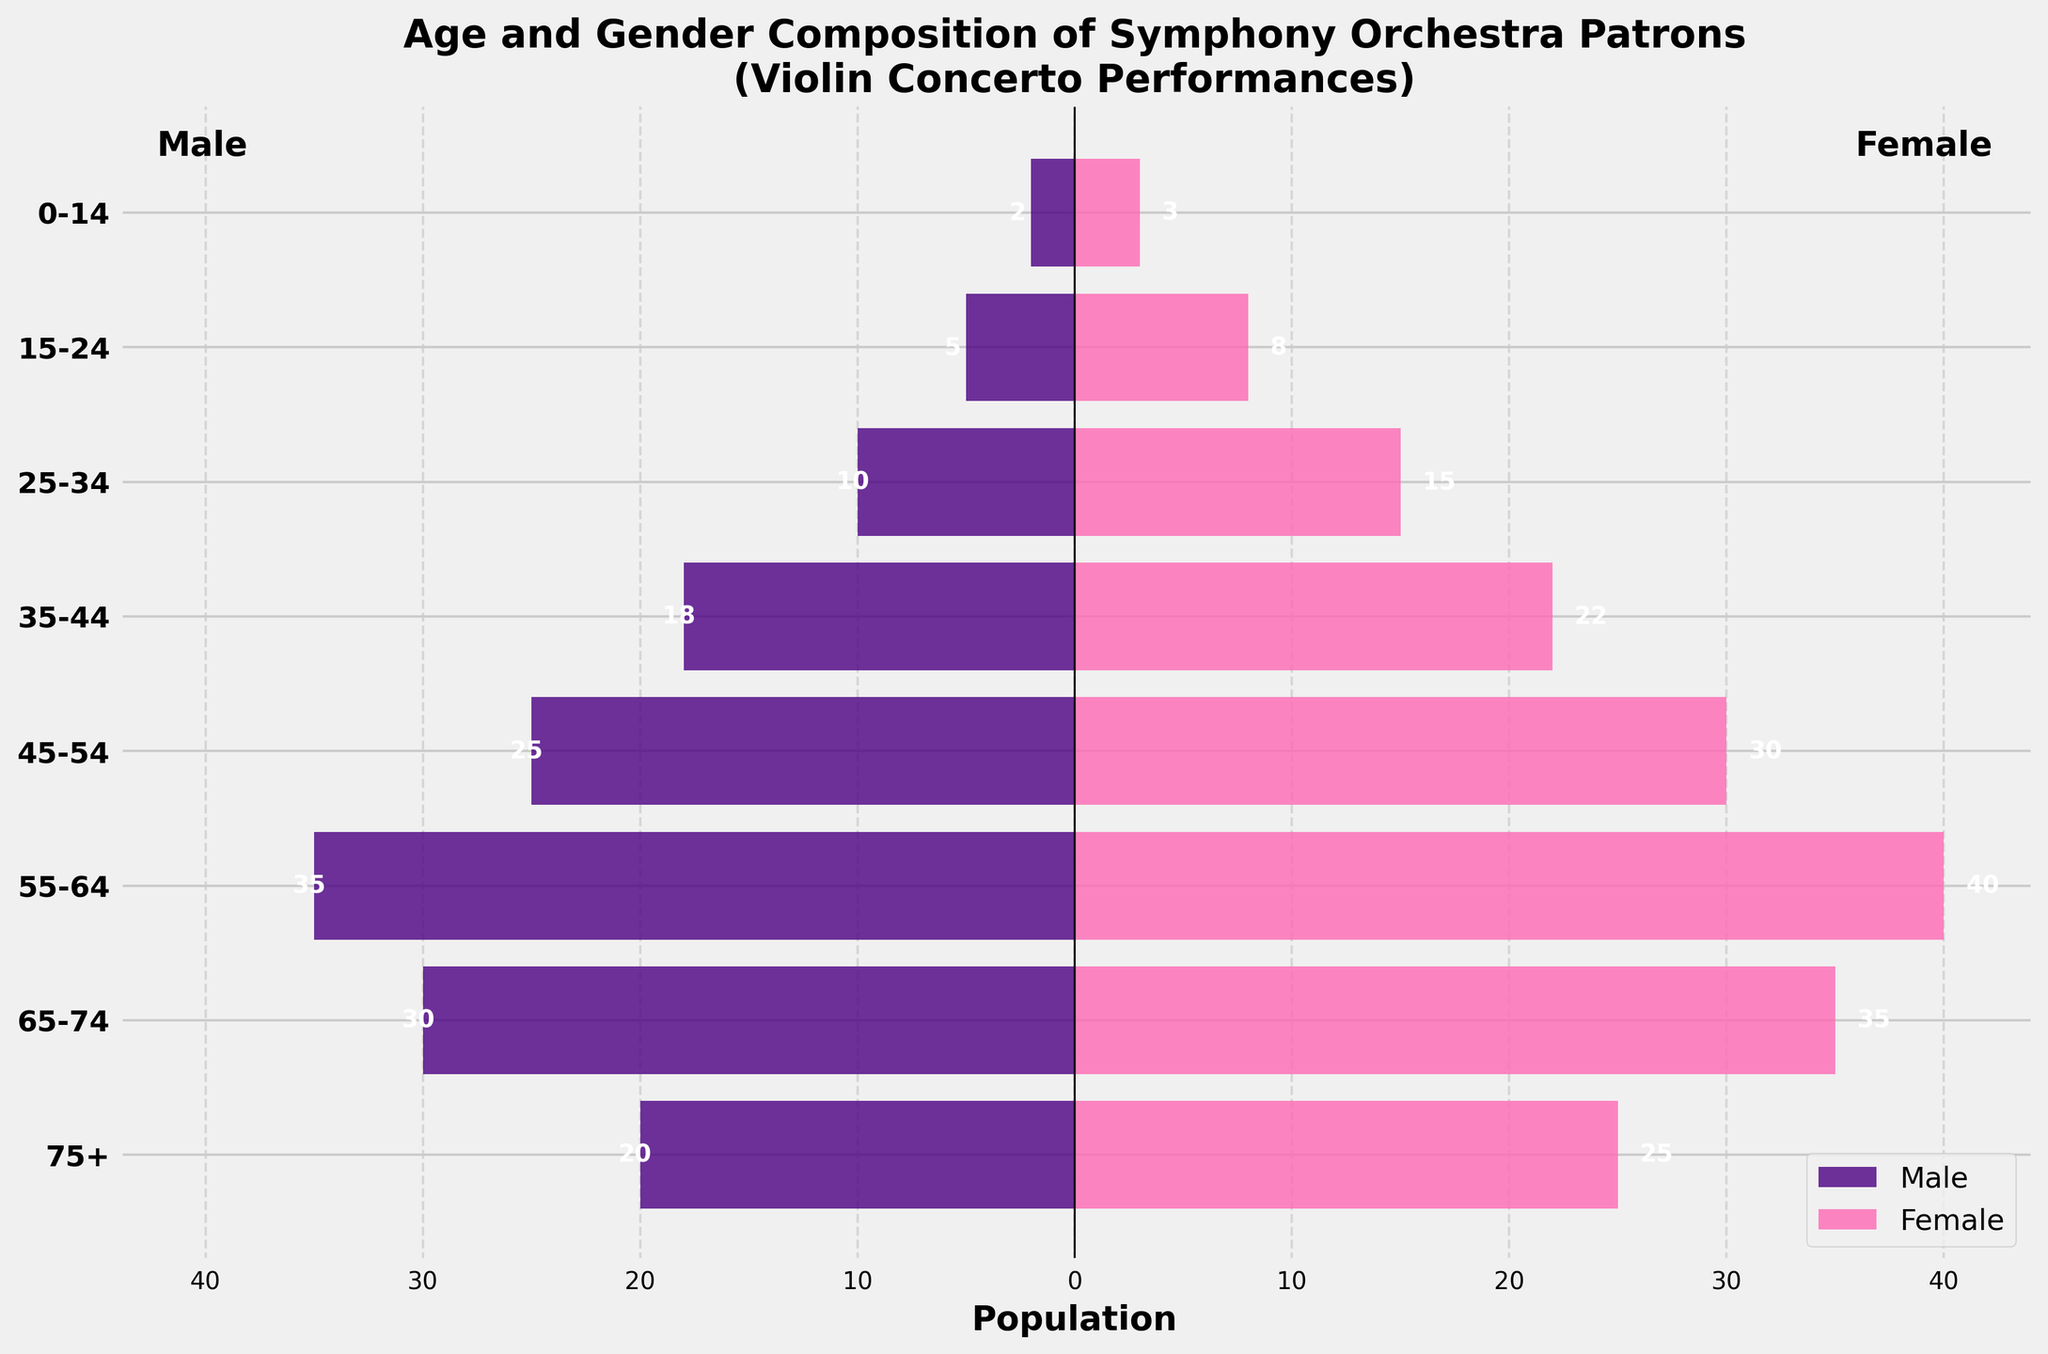What is the title of the plot? The title is given at the top of the plot, providing context for the data being displayed.
Answer: Age and Gender Composition of Symphony Orchestra Patrons (Violin Concerto Performances) How many male patrons are in the age group 55-64? Locate the bar representing the age group 55-64 on the left side (male). Read the negative value indicated on the bar.
Answer: 35 Which age group has the highest female patron population? Compare the lengths of the pink bars representing female patrons across all age groups. The age group with the longest bar has the highest population.
Answer: 55-64 What is the total number of patrons in the age group 65-74? Add together the values of male and female patrons in the age group 65-74. Male value is 30 and female value is 35. 30 + 35 = 65
Answer: 65 In which age group is the male patron population closest to the female patron population? Compare the lengths of the blue (male) bars and pink (female) bars for each age group. The age group where the difference is smallest between the two values is the answer.
Answer: 65-74 How many more female patrons are there compared to male patrons in the age group 35-44? Subtract the male patron population from the female patron population in the age group 35-44. Female value is 22, male value is 18. 22 - 18 = 4
Answer: 4 Which age group has the fewest total patrons? Look for the shortest combined length of the blue (male) and pink (female) bars. The age group with the shortest total bar length has the fewest patrons.
Answer: 0-14 How does the number of male patrons in the age group 45-54 compare to that in the age group 75+? Compare the length of the blue bar for the age group 45-54 with the length of the blue bar for the age group 75+. The bar for 45-54 is longer. 45-54 has 25 and 75+ has 20.
Answer: More in 45-54 Which gender has a higher population in the age group 15-24? Compare the lengths of the blue (male) and pink (female) bars in the age group 15-24. The longest bar indicates the gender with the higher population.
Answer: Female What is the combined total of male and female patrons across all age groups? Sum the values of male and female patrons for all age groups. 2+5+10+18+25+35+30+20 (Male) and 3+8+15+22+30+40+35+25 (Female) = 145 (Male) + 178 (Female) = 323
Answer: 323 